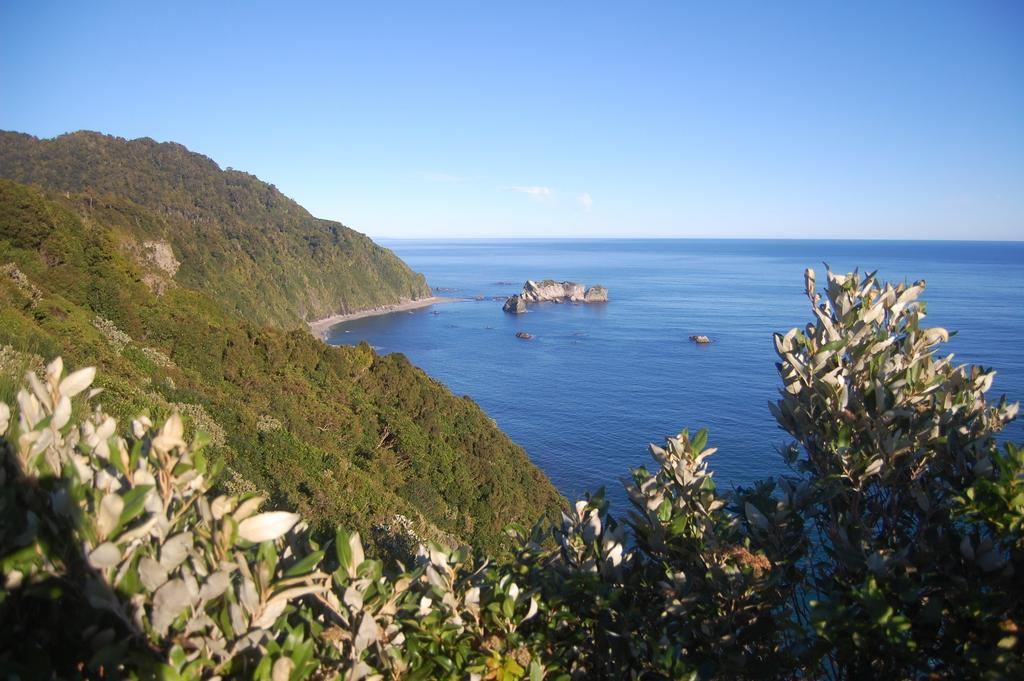What type of natural elements can be seen in the image? There are trees and rocks visible in the image. What else can be seen in the image besides trees and rocks? There is water visible in the image. What is visible in the background of the image? The sky is visible in the image. What is the tax rate for the trees in the image? There is no tax rate mentioned or implied in the image, as it features natural elements like trees and rocks. 